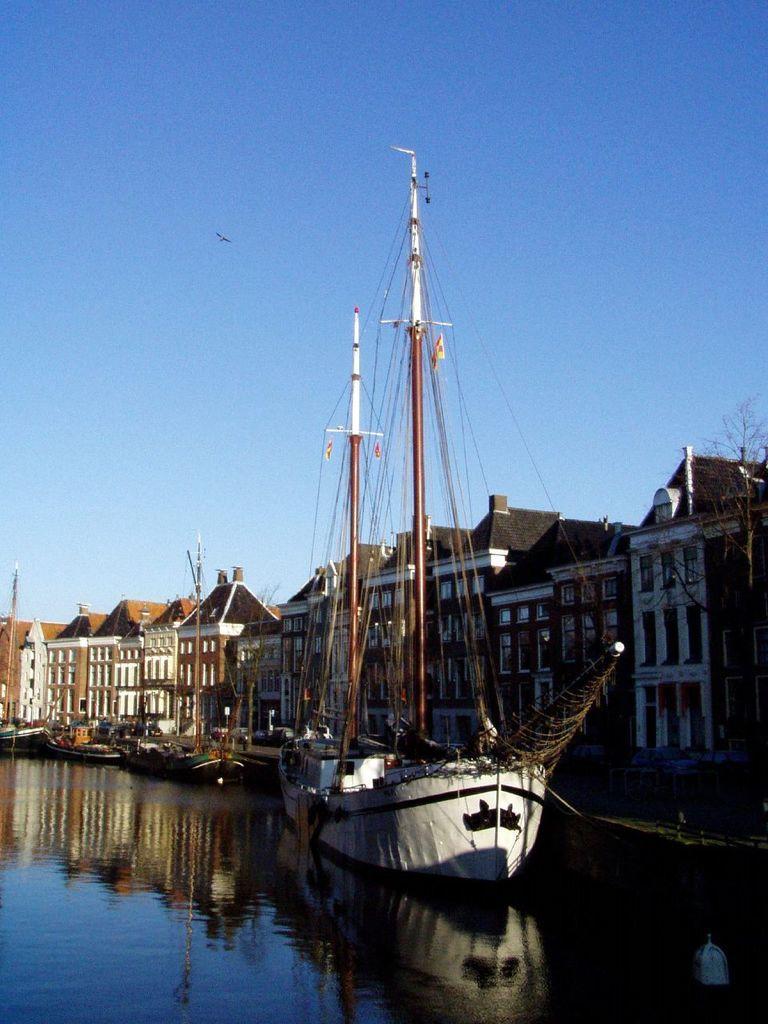Could you give a brief overview of what you see in this image? In this image there are few ships in the water, there are few buildings, a tree, a bird flying in the sky. 